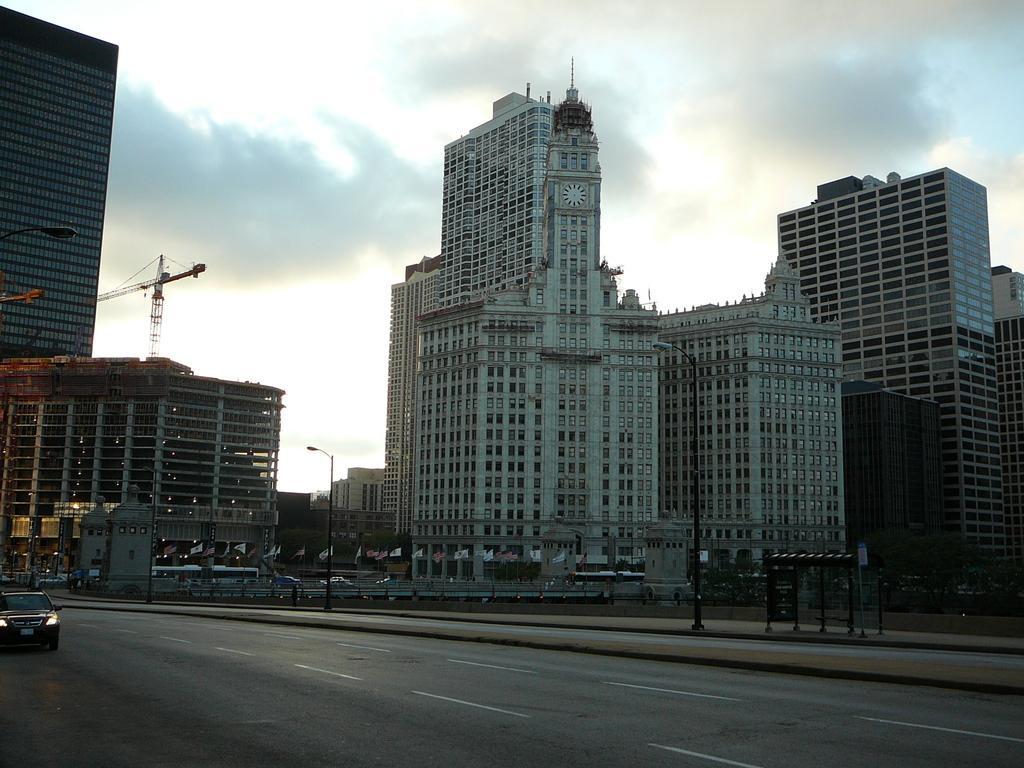Can you describe this image briefly? In this image there are buildings and poles. We can see a crane. There are vehicles on the road. We can see flags. In the background there is sky. 